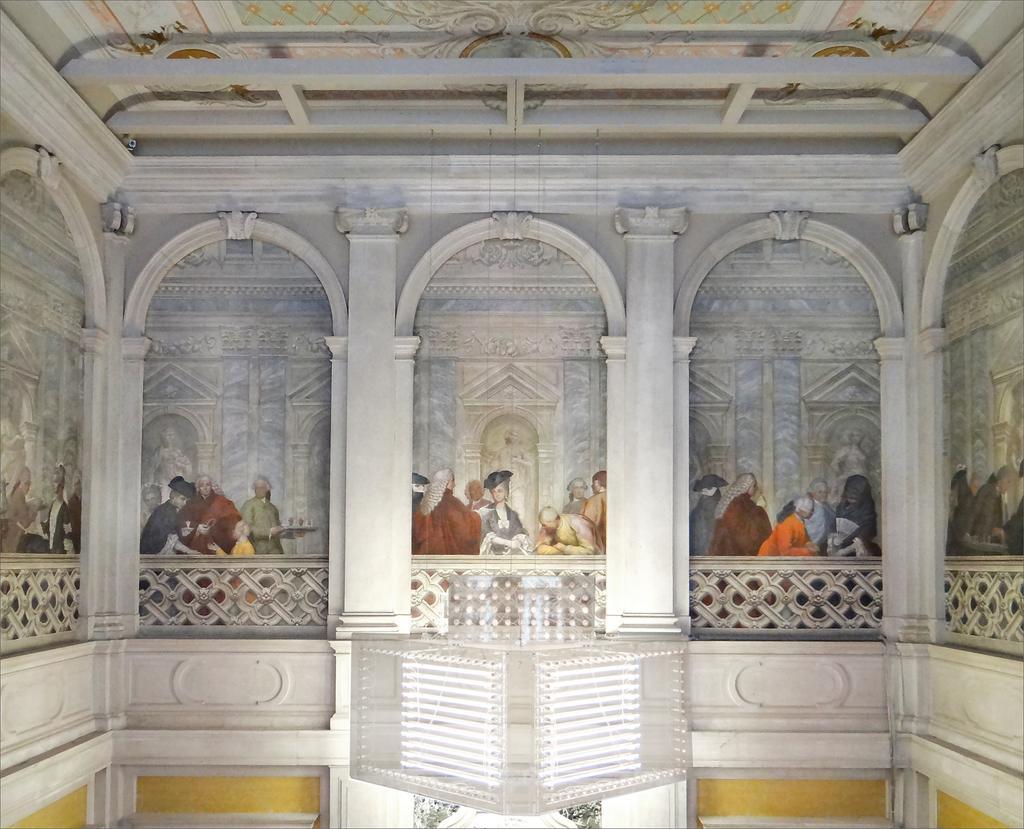Describe this image in one or two sentences. In this image we can see a painting. This is an inside view of a building. Also there are people. And there are pillars and railings. 